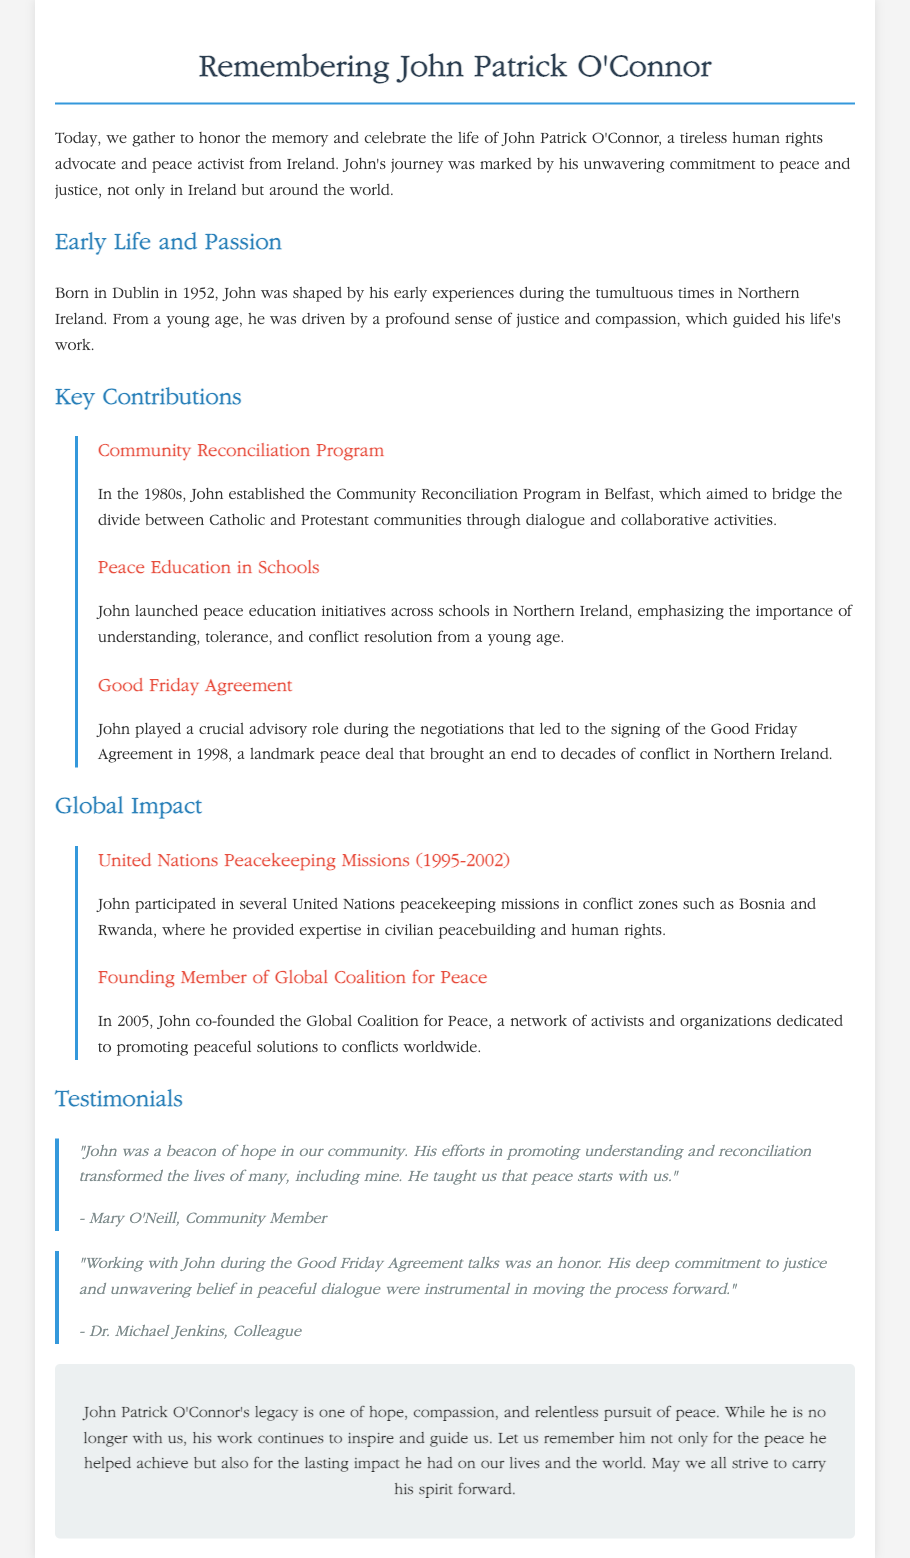what year was John born? John Patrick O'Connor was born in 1952.
Answer: 1952 what is the name of the initiative John established in Belfast? The initiative established by John in Belfast is called the Community Reconciliation Program.
Answer: Community Reconciliation Program which peace agreement did John play a role in? John played a crucial advisory role in the negotiations of the Good Friday Agreement.
Answer: Good Friday Agreement how many years did John participate in United Nations peacekeeping missions? John participated in United Nations peacekeeping missions from 1995 to 2002, which is 7 years.
Answer: 7 years who is Mary O'Neill in relation to John? Mary O'Neill is a community member who provided a testimonial about John's impact.
Answer: community member what significant global organization did John co-found in 2005? John co-founded the Global Coalition for Peace in 2005.
Answer: Global Coalition for Peace how did John's work influence the lives of people? John's work helped to transform the lives of many through promoting understanding and reconciliation.
Answer: transformed the lives what type of legacy did John leave behind? John Patrick O'Connor's legacy is one of hope, compassion, and relentless pursuit of peace.
Answer: hope, compassion, and relentless pursuit of peace who expressed honor in working with John during the Good Friday Agreement talks? Dr. Michael Jenkins expressed honor in working with John during the Good Friday Agreement talks.
Answer: Dr. Michael Jenkins 